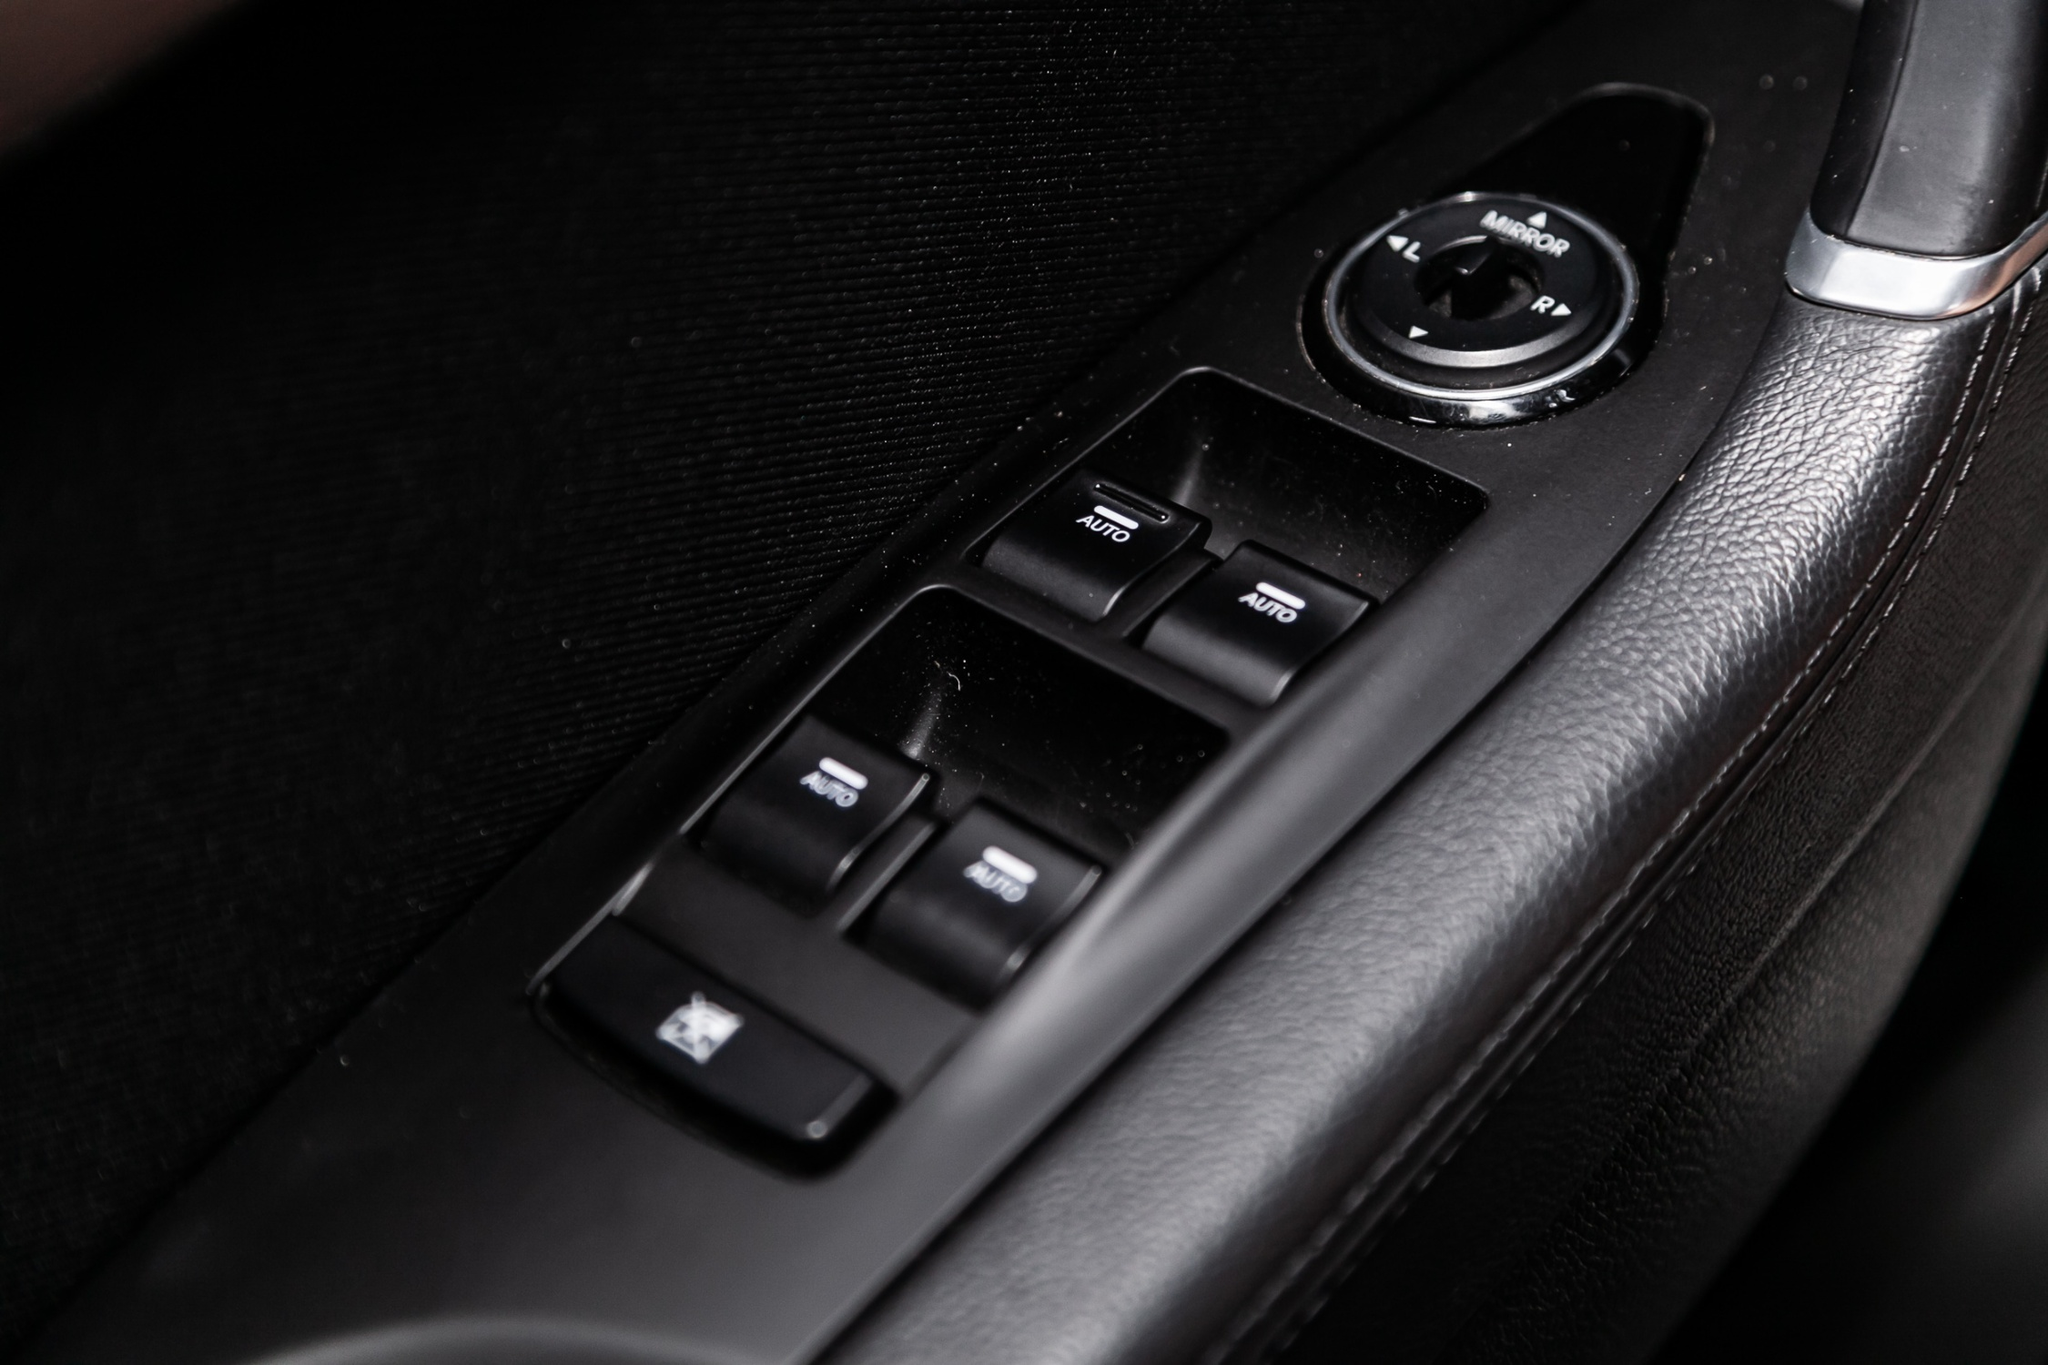Could you explain the purpose of each button shown in this image? Certainly! The image shows several buttons within the driver's side door control panel. Here's a breakdown of their purposes:
1. 'AUTO' Buttons: These are for the automatic control of the car's windows. pressing these buttons allows the windows to be raised or lowered automatically.
2. 'PWR' Button: This typically refers to a power setting, possibly for enabling or disabling power functions in the vehicle, such as power windows or locks.
3. Window Icon Button: This button is likely used to control a specific window, allowing the driver to raise or lower that window manually.
4. Lock Icon Button: This button is used to lock or unlock the car doors from the driver's side.
5. Circular Mirror Adjustment Knob: This knob is used to adjust the side mirrors' positions, allowing the driver to ensure they have the best view around the car for safety. Can you tell me more about the materials used in this design? Absolutely! The design of the door panel emphasizes both luxury and functionality through the choice of materials. The armrest and surrounding areas appear to be covered in high-quality black leather, providing a premium feel that is also comfortable for the driver. The buttons and control panel are likely made from durable plastic with a matte finish, giving them a sleek yet tactile experience. The silver handle, possibly made of brushed aluminum or a coated metal, adds a touch of elegance and contrast to the predominantly black color scheme. These materials are carefully selected to create a cohesive and appealing aesthetic while ensuring durability and ease of maintenance. 